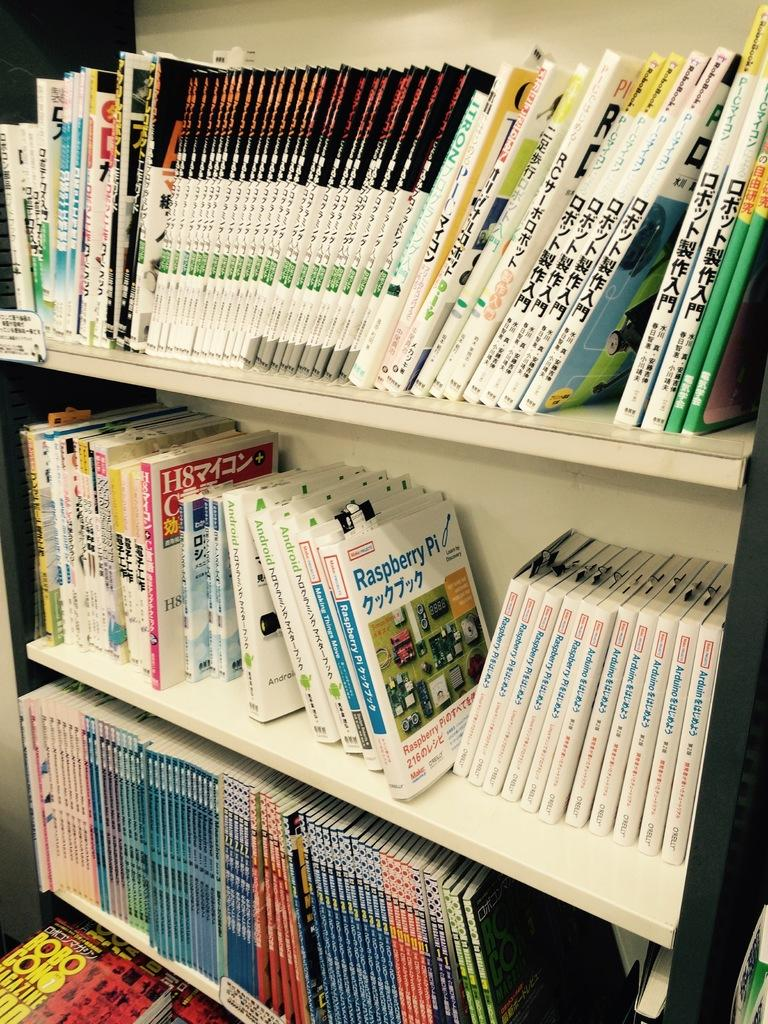<image>
Provide a brief description of the given image. A book on the second shelf of shows a title of Raspberry Pi. 